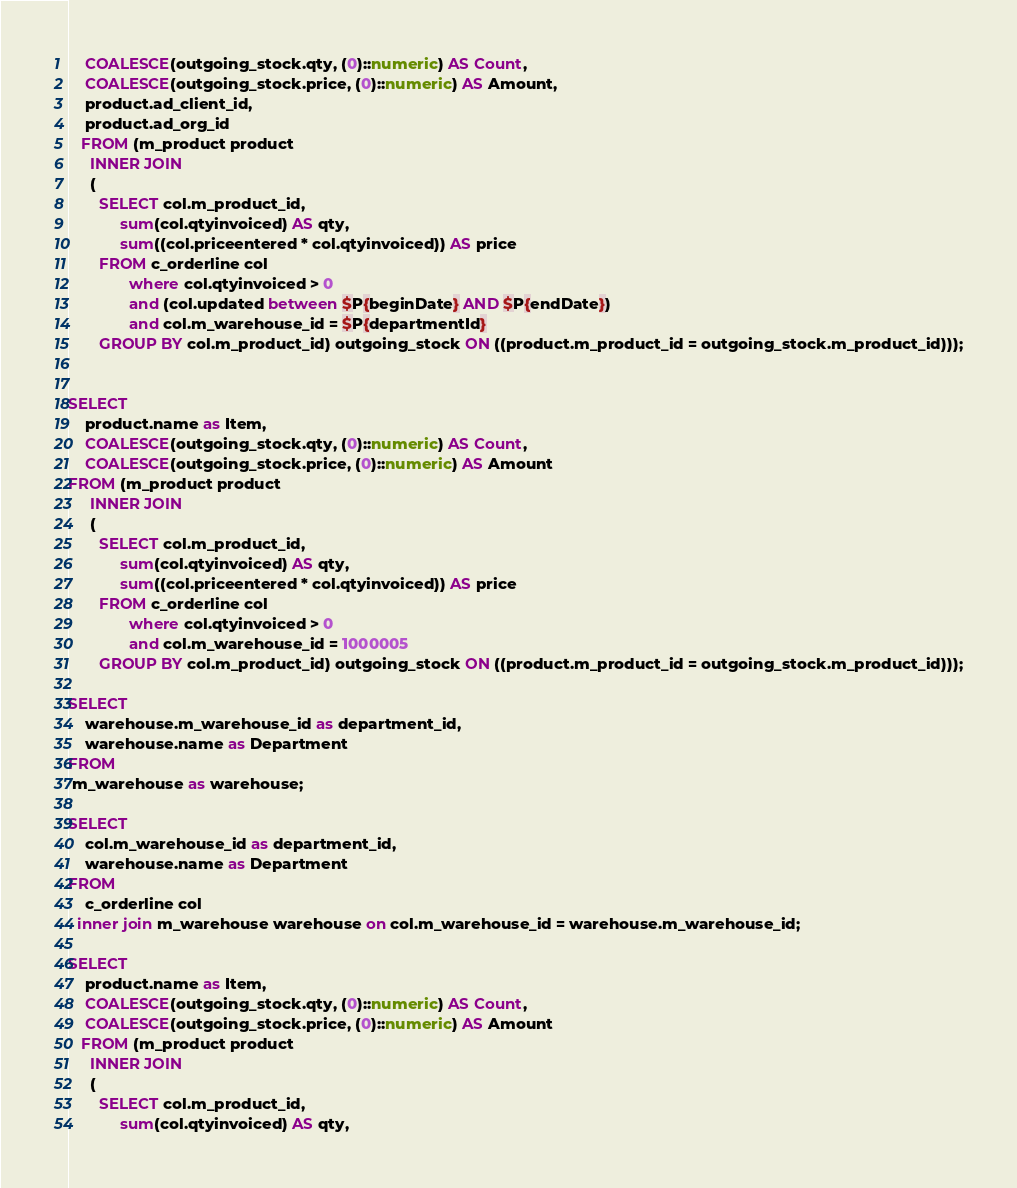Convert code to text. <code><loc_0><loc_0><loc_500><loc_500><_SQL_>    COALESCE(outgoing_stock.qty, (0)::numeric) AS Count,
    COALESCE(outgoing_stock.price, (0)::numeric) AS Amount,
    product.ad_client_id,
    product.ad_org_id
   FROM (m_product product
     INNER JOIN
     (
       SELECT col.m_product_id,
            sum(col.qtyinvoiced) AS qty,
            sum((col.priceentered * col.qtyinvoiced)) AS price
       FROM c_orderline col
              where col.qtyinvoiced > 0
              and (col.updated between $P{beginDate} AND $P{endDate})
              and col.m_warehouse_id = $P{departmentId}
       GROUP BY col.m_product_id) outgoing_stock ON ((product.m_product_id = outgoing_stock.m_product_id)));


SELECT
    product.name as Item,
    COALESCE(outgoing_stock.qty, (0)::numeric) AS Count,
    COALESCE(outgoing_stock.price, (0)::numeric) AS Amount
FROM (m_product product
     INNER JOIN
     (
       SELECT col.m_product_id,
            sum(col.qtyinvoiced) AS qty,
            sum((col.priceentered * col.qtyinvoiced)) AS price
       FROM c_orderline col
              where col.qtyinvoiced > 0
              and col.m_warehouse_id = 1000005
       GROUP BY col.m_product_id) outgoing_stock ON ((product.m_product_id = outgoing_stock.m_product_id)));

SELECT
    warehouse.m_warehouse_id as department_id,
    warehouse.name as Department
FROM
 m_warehouse as warehouse;

SELECT
    col.m_warehouse_id as department_id,
    warehouse.name as Department
FROM
    c_orderline col
  inner join m_warehouse warehouse on col.m_warehouse_id = warehouse.m_warehouse_id;

SELECT
    product.name as Item,
    COALESCE(outgoing_stock.qty, (0)::numeric) AS Count,
    COALESCE(outgoing_stock.price, (0)::numeric) AS Amount
   FROM (m_product product
     INNER JOIN
     (
       SELECT col.m_product_id,
            sum(col.qtyinvoiced) AS qty,</code> 